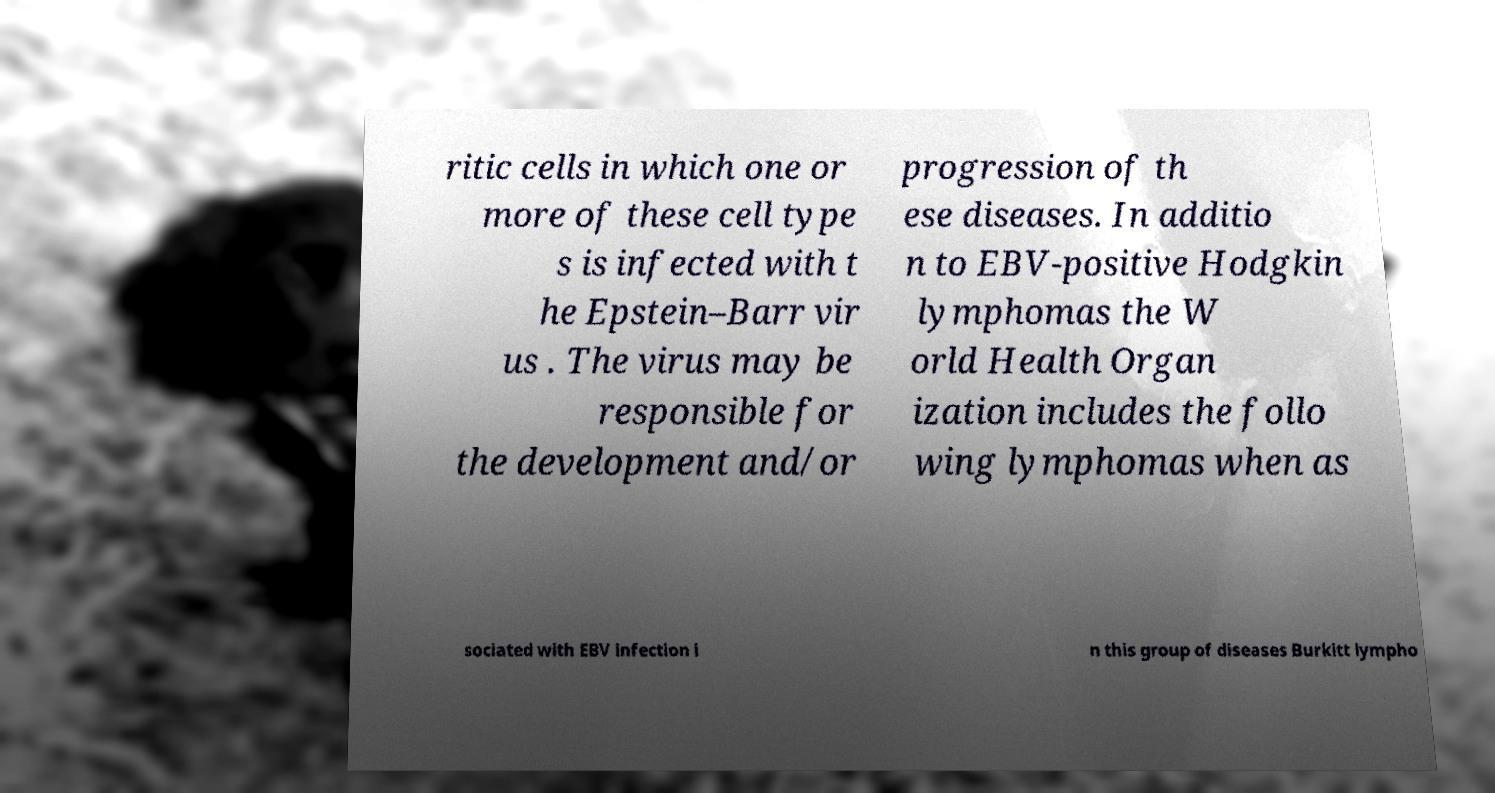Please read and relay the text visible in this image. What does it say? ritic cells in which one or more of these cell type s is infected with t he Epstein–Barr vir us . The virus may be responsible for the development and/or progression of th ese diseases. In additio n to EBV-positive Hodgkin lymphomas the W orld Health Organ ization includes the follo wing lymphomas when as sociated with EBV infection i n this group of diseases Burkitt lympho 